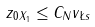Convert formula to latex. <formula><loc_0><loc_0><loc_500><loc_500>\| z _ { 0 } \| _ { X _ { 1 } } \leq C _ { N } \| v \| _ { \L s }</formula> 